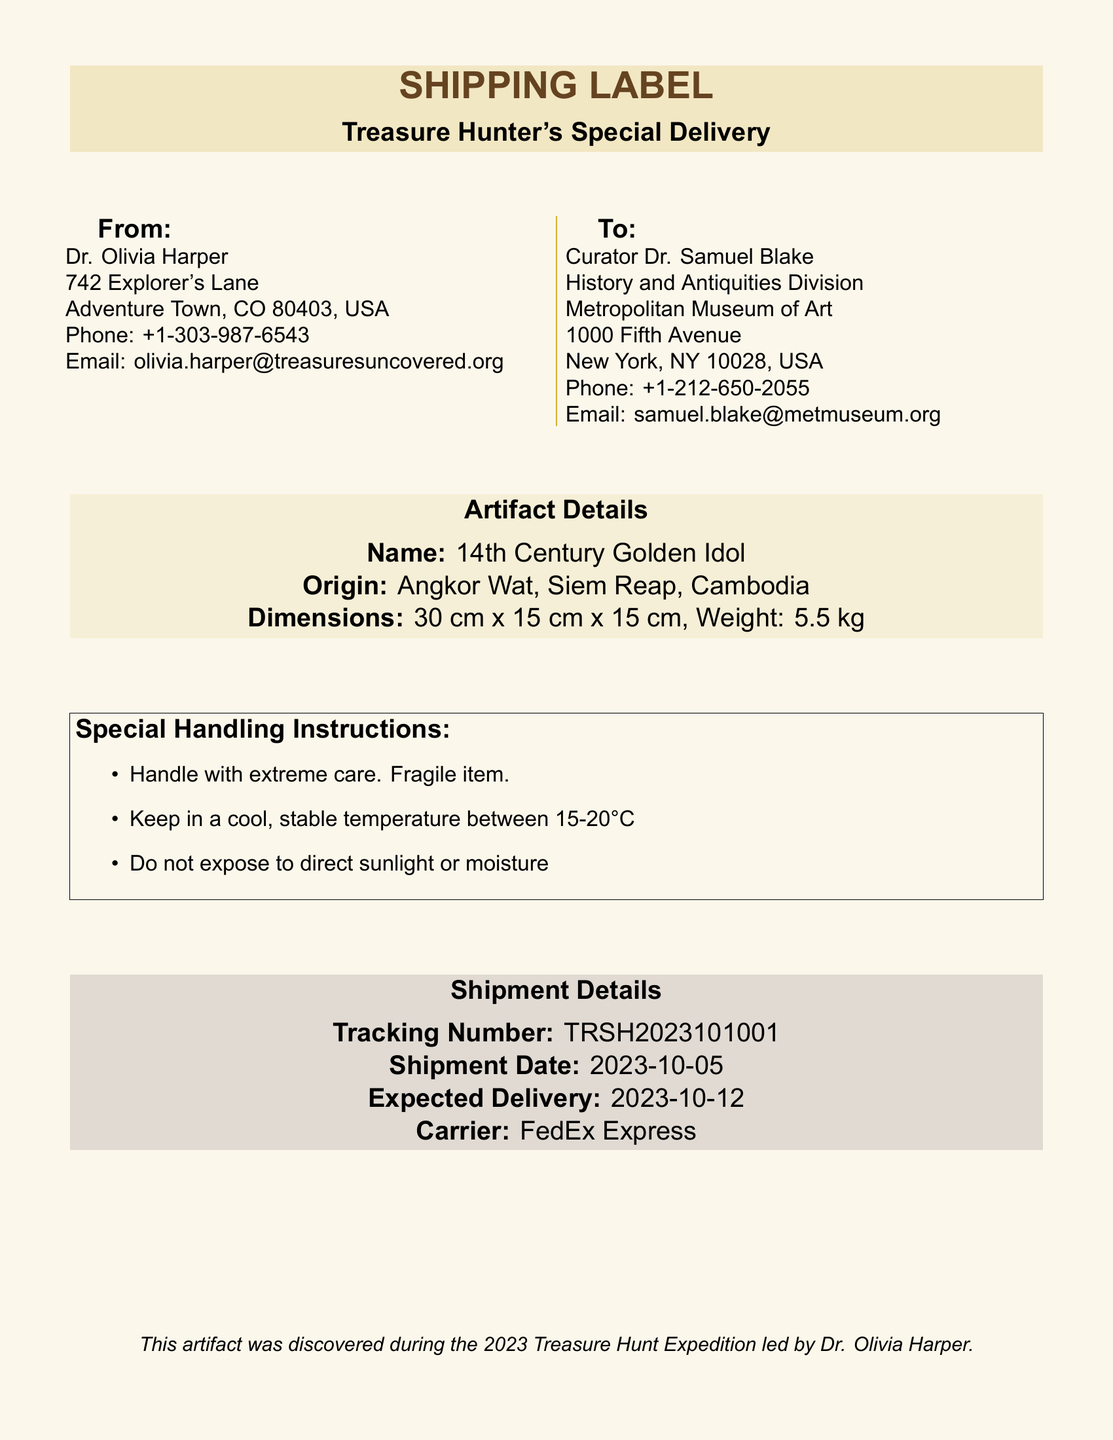What is the name of the artifact? The name of the artifact is explicitly mentioned in the document as "14th Century Golden Idol."
Answer: 14th Century Golden Idol Where is the artifact from? The origin of the artifact is specified in the document as "Angkor Wat, Siem Reap, Cambodia."
Answer: Angkor Wat, Siem Reap, Cambodia What is the weight of the artifact? The weight of the artifact is provided in the document as "5.5 kg."
Answer: 5.5 kg Who is the recipient of this shipment? The recipient's name is listed in the document as "Curator Dr. Samuel Blake."
Answer: Curator Dr. Samuel Blake What is the tracking number for this shipment? The tracking number is indicated in the document as "TRSH2023101001."
Answer: TRSH2023101001 What is the expected delivery date? The document states the expected delivery date as "2023-10-12."
Answer: 2023-10-12 What temperature should the artifact be kept in? The document specifies that the artifact should be kept in a temperature between "15-20°C."
Answer: 15-20°C Who led the 2023 Treasure Hunt Expedition? The document notes that Dr. Olivia Harper led the expedition where the artifact was discovered.
Answer: Dr. Olivia Harper What carrier is being used for shipment? The carrier is mentioned in the document as "FedEx Express."
Answer: FedEx Express 